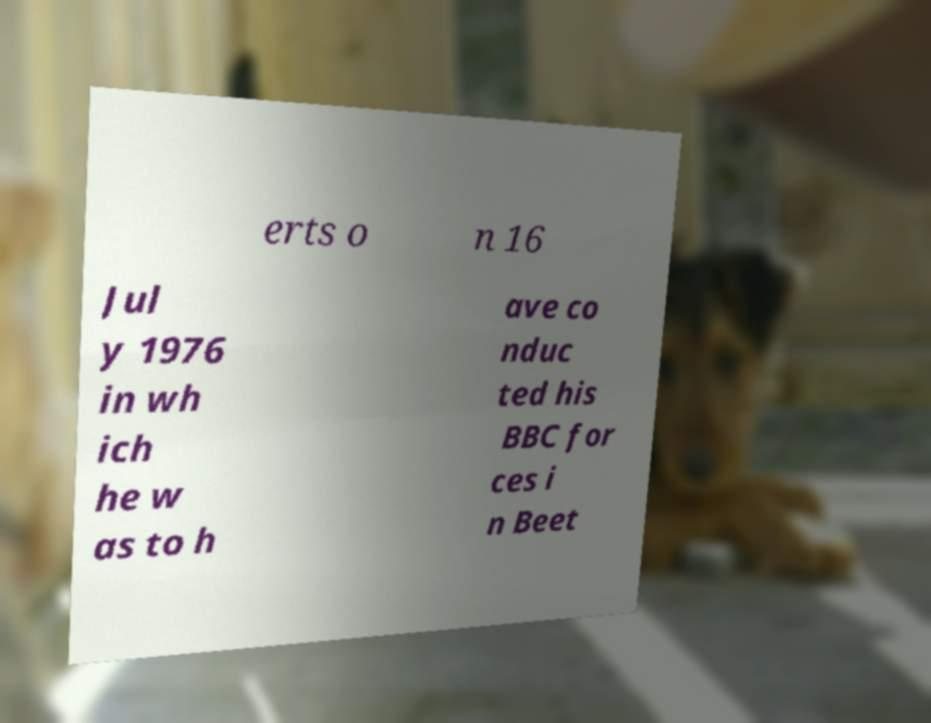Can you read and provide the text displayed in the image?This photo seems to have some interesting text. Can you extract and type it out for me? erts o n 16 Jul y 1976 in wh ich he w as to h ave co nduc ted his BBC for ces i n Beet 